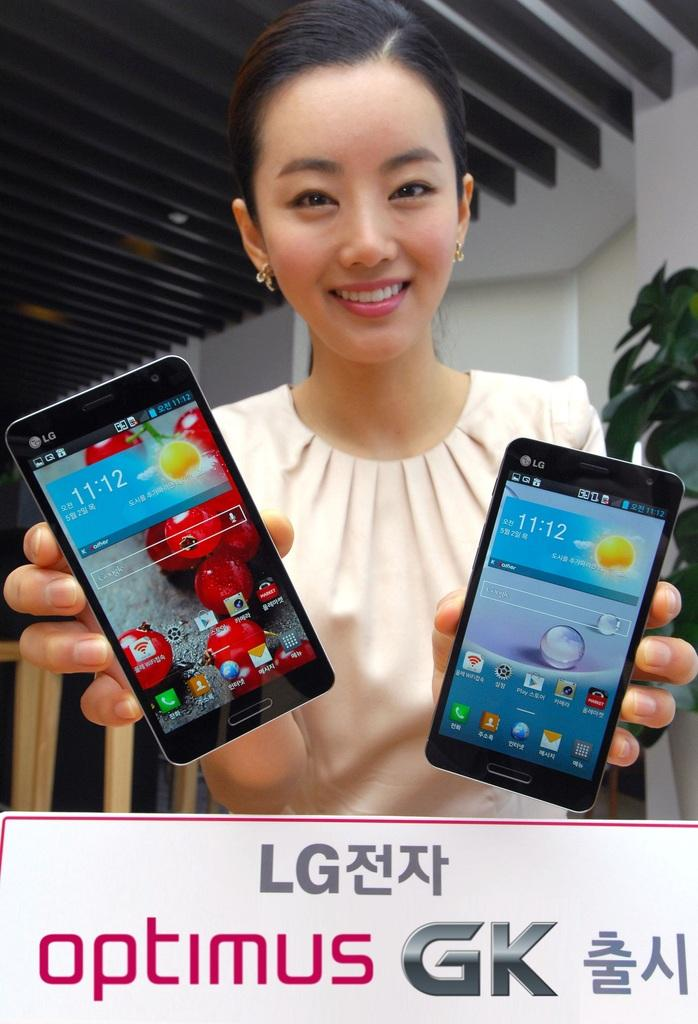<image>
Give a short and clear explanation of the subsequent image. a lady that is holding an optimus phone in her hands 